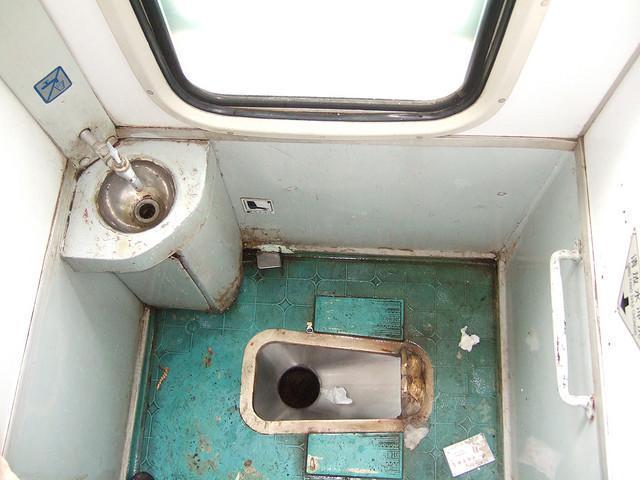How many slices of pizza are left?
Give a very brief answer. 0. 